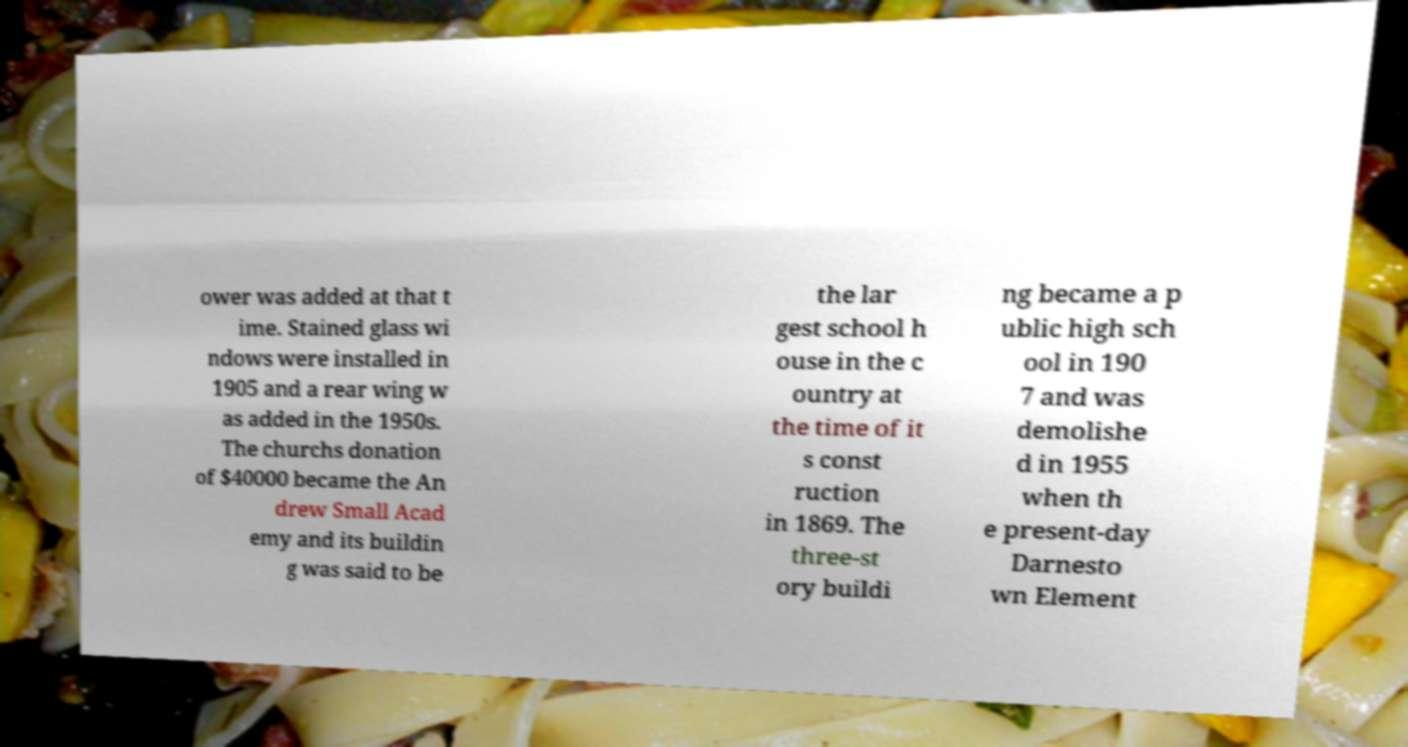Please read and relay the text visible in this image. What does it say? ower was added at that t ime. Stained glass wi ndows were installed in 1905 and a rear wing w as added in the 1950s. The churchs donation of $40000 became the An drew Small Acad emy and its buildin g was said to be the lar gest school h ouse in the c ountry at the time of it s const ruction in 1869. The three-st ory buildi ng became a p ublic high sch ool in 190 7 and was demolishe d in 1955 when th e present-day Darnesto wn Element 